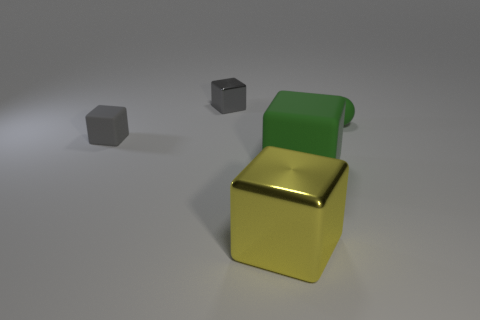Is there anything else that has the same color as the small matte sphere? Yes, the large cube in the background shares a similar shade of gray with the small matte sphere, indicating an element of uniformity in color palette within the image. 